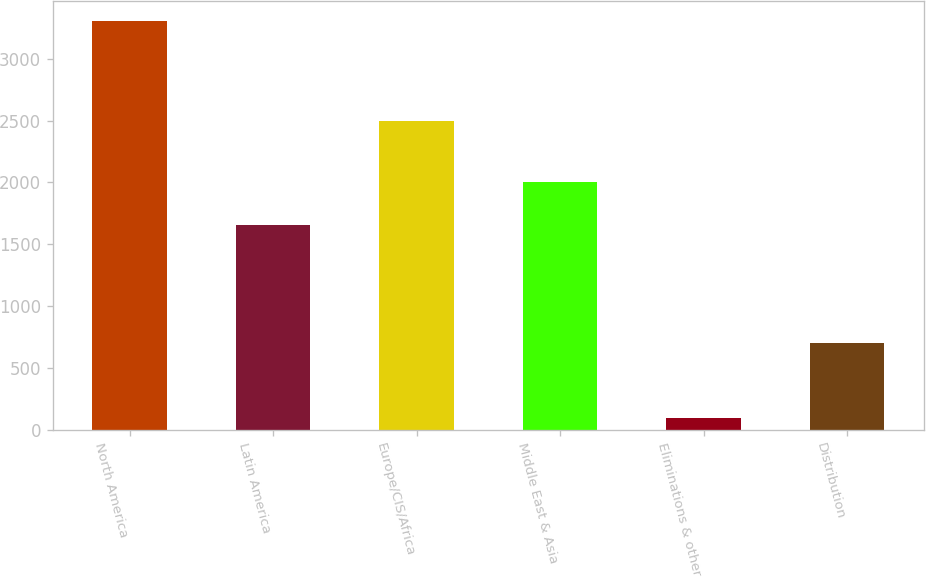Convert chart. <chart><loc_0><loc_0><loc_500><loc_500><bar_chart><fcel>North America<fcel>Latin America<fcel>Europe/CIS/Africa<fcel>Middle East & Asia<fcel>Eliminations & other<fcel>Distribution<nl><fcel>3304<fcel>1655<fcel>2494<fcel>2003<fcel>90<fcel>698<nl></chart> 